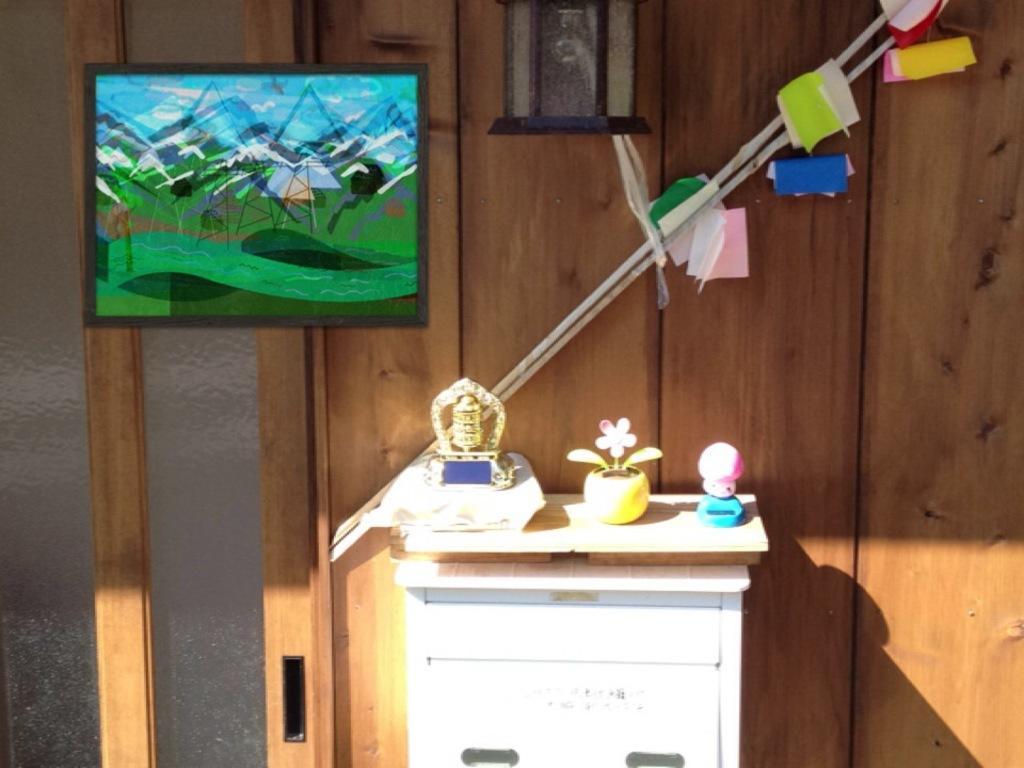Could you give a brief overview of what you see in this image? In this picture we can see a table and on table we have toy, flower pot, some item and in background we can see wall, frame, sticks, some papers. 